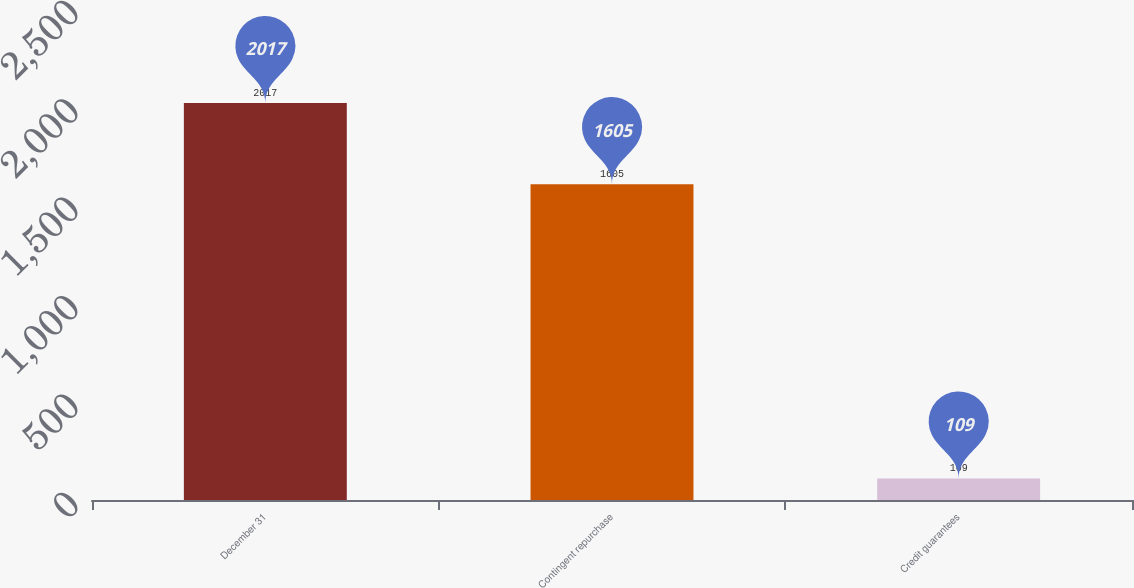<chart> <loc_0><loc_0><loc_500><loc_500><bar_chart><fcel>December 31<fcel>Contingent repurchase<fcel>Credit guarantees<nl><fcel>2017<fcel>1605<fcel>109<nl></chart> 